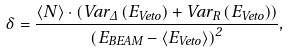Convert formula to latex. <formula><loc_0><loc_0><loc_500><loc_500>\delta = \frac { \langle N \rangle \cdot \left ( V a r _ { \Delta } \left ( E _ { V e t o } \right ) + V a r _ { R } \left ( E _ { V e t o } \right ) \right ) } { \left ( E _ { B E A M } - \langle E _ { V e t o } \rangle \right ) ^ { 2 } } ,</formula> 